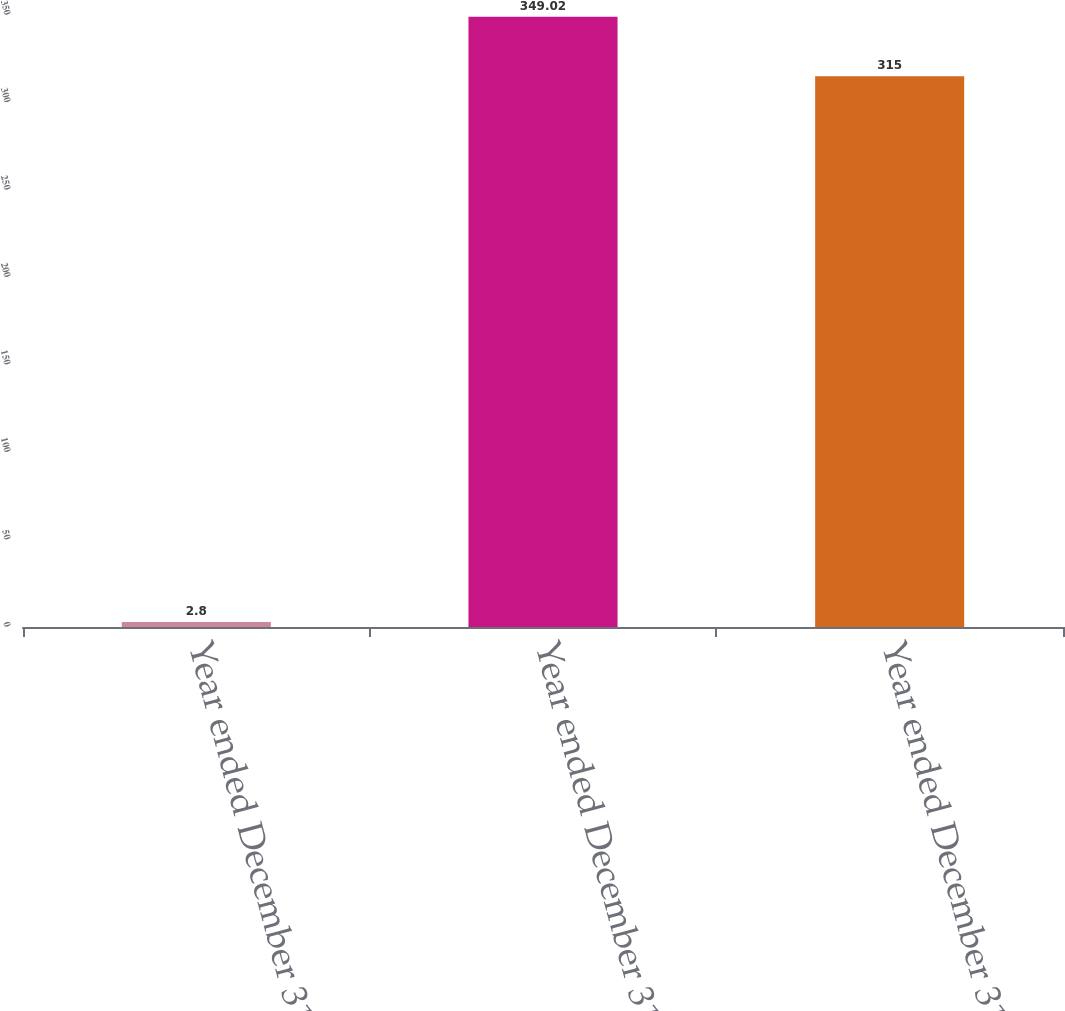Convert chart to OTSL. <chart><loc_0><loc_0><loc_500><loc_500><bar_chart><fcel>Year ended December 31 2012<fcel>Year ended December 31 2011<fcel>Year ended December 31 2010<nl><fcel>2.8<fcel>349.02<fcel>315<nl></chart> 